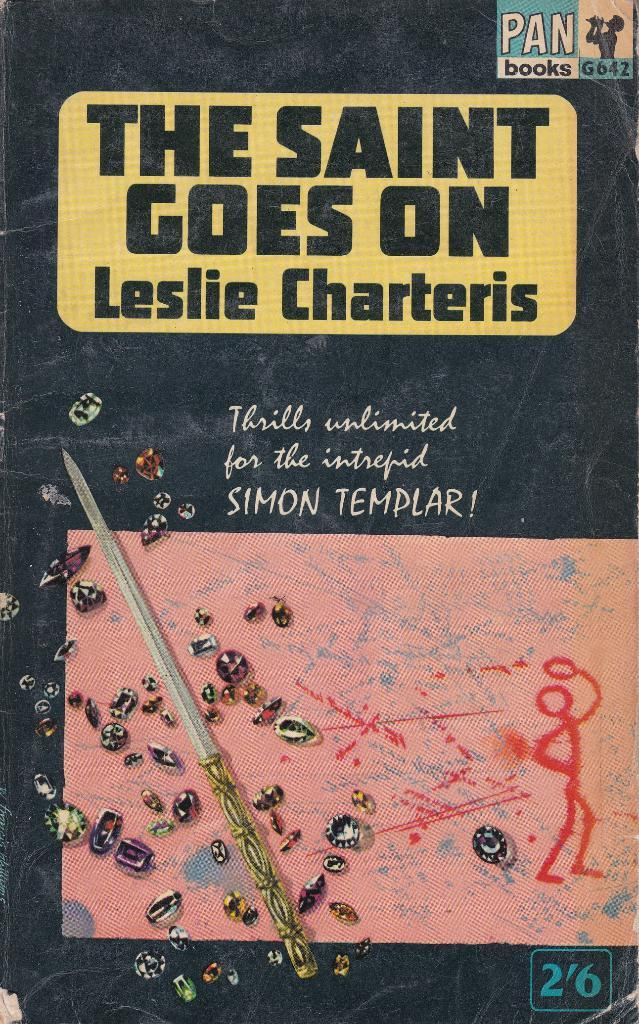Provide a one-sentence caption for the provided image. A paperback featuring the Simon Templar character claims to offer thrills unlimited. 